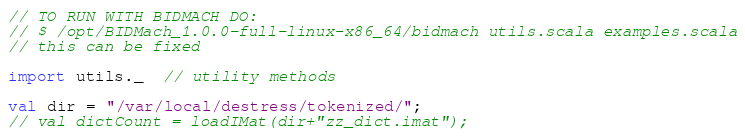<code> <loc_0><loc_0><loc_500><loc_500><_Scala_>// TO RUN WITH BIDMACH DO:
// $ /opt/BIDMach_1.0.0-full-linux-x86_64/bidmach utils.scala examples.scala
// this can be fixed

import utils._  // utility methods

val dir = "/var/local/destress/tokenized/";
// val dictCount = loadIMat(dir+"zz_dict.imat");</code> 